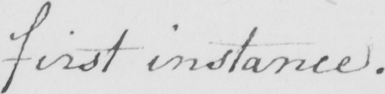Please provide the text content of this handwritten line. first instance . 